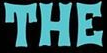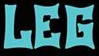Read the text content from these images in order, separated by a semicolon. THE; LEG 